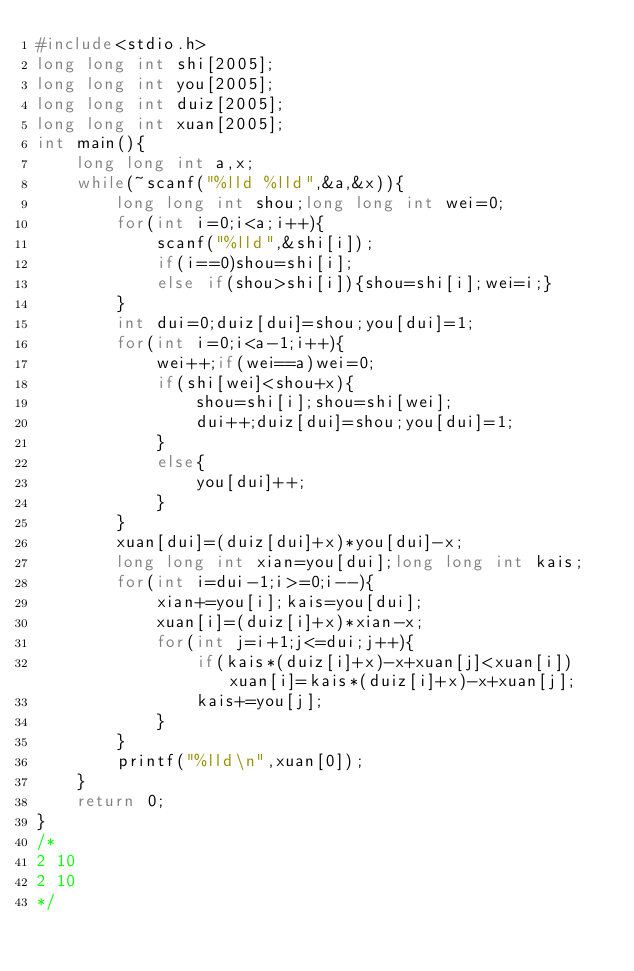Convert code to text. <code><loc_0><loc_0><loc_500><loc_500><_C++_>#include<stdio.h>
long long int shi[2005];
long long int you[2005];
long long int duiz[2005];
long long int xuan[2005];
int main(){
    long long int a,x;
    while(~scanf("%lld %lld",&a,&x)){
        long long int shou;long long int wei=0;
        for(int i=0;i<a;i++){
            scanf("%lld",&shi[i]);
            if(i==0)shou=shi[i];
            else if(shou>shi[i]){shou=shi[i];wei=i;}
        }
        int dui=0;duiz[dui]=shou;you[dui]=1;
        for(int i=0;i<a-1;i++){
            wei++;if(wei==a)wei=0;
            if(shi[wei]<shou+x){
                shou=shi[i];shou=shi[wei];
                dui++;duiz[dui]=shou;you[dui]=1;
            }
            else{
                you[dui]++;
            }
        }
        xuan[dui]=(duiz[dui]+x)*you[dui]-x;
        long long int xian=you[dui];long long int kais;
        for(int i=dui-1;i>=0;i--){
            xian+=you[i];kais=you[dui];
            xuan[i]=(duiz[i]+x)*xian-x;
            for(int j=i+1;j<=dui;j++){
                if(kais*(duiz[i]+x)-x+xuan[j]<xuan[i])xuan[i]=kais*(duiz[i]+x)-x+xuan[j];
                kais+=you[j];
            }
        }
        printf("%lld\n",xuan[0]);
    }
    return 0;
}
/*
2 10
2 10
*/
</code> 